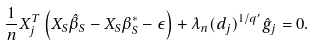<formula> <loc_0><loc_0><loc_500><loc_500>\frac { 1 } { n } X _ { j } ^ { T } \left ( X _ { S } \hat { \beta } _ { S } - X _ { S } \beta ^ { * } _ { S } - \epsilon \right ) + \lambda _ { n } ( d _ { j } ) ^ { 1 / q ^ { \prime } } \hat { g } _ { j } = 0 .</formula> 